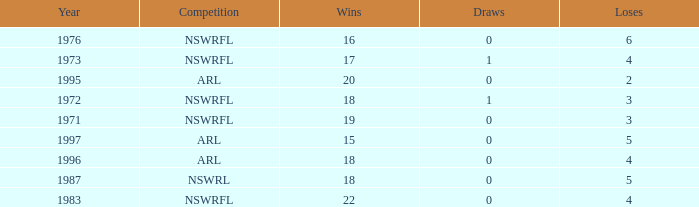What sum of Losses has Year greater than 1972, and Competition of nswrfl, and Draws 0, and Wins 16? 6.0. Write the full table. {'header': ['Year', 'Competition', 'Wins', 'Draws', 'Loses'], 'rows': [['1976', 'NSWRFL', '16', '0', '6'], ['1973', 'NSWRFL', '17', '1', '4'], ['1995', 'ARL', '20', '0', '2'], ['1972', 'NSWRFL', '18', '1', '3'], ['1971', 'NSWRFL', '19', '0', '3'], ['1997', 'ARL', '15', '0', '5'], ['1996', 'ARL', '18', '0', '4'], ['1987', 'NSWRL', '18', '0', '5'], ['1983', 'NSWRFL', '22', '0', '4']]} 